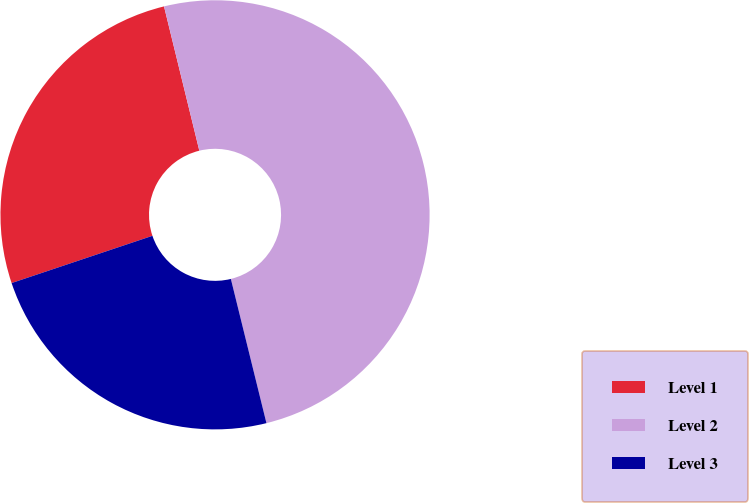<chart> <loc_0><loc_0><loc_500><loc_500><pie_chart><fcel>Level 1<fcel>Level 2<fcel>Level 3<nl><fcel>26.33%<fcel>49.97%<fcel>23.7%<nl></chart> 